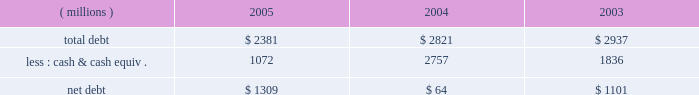Additional information regarding these and other accounting pronouncements is included in note 1 to the consolidated financial statements .
Financial condition and liquidity the company generates significant ongoing cash flow .
Net debt decreased significantly in 2004 , but increased in 2005 , primarily related to the $ 1.36 billion cuno acquisition .
At december 31 .
3m believes its ongoing cash flows provide ample cash to fund expected investments and capital expenditures .
The company has an aa credit rating from standard & poor 2019s and an aa1 credit rating from moody 2019s investors service .
The company has sufficient access to capital markets to meet currently anticipated growth and acquisition investment funding needs .
The company does not utilize derivative instruments linked to the company 2019s stock .
However , the company does have contingently convertible debt that , if conditions for conversion are met , is convertible into shares of 3m common stock ( refer to note 8 in this document ) .
The company 2019s financial condition and liquidity at december 31 , 2005 , remained strong .
Various assets and liabilities , including cash and short-term debt , can fluctuate significantly from month-to-month depending on short-term liquidity needs .
Working capital ( defined as current assets minus current liabilities ) totaled $ 1.877 billion at december 31 , 2005 , compared with $ 2.649 billion at december 31 , 2004 .
This decrease was primarily related to a decrease in cash and cash equivalents ( $ 1.685 billion ) partially offset by a decrease in debt classified as short-term borrowings and current portion of long-term debt ( $ 1.022 billion ) .
The cash and cash equivalents balance was impacted by the acquisition of cuno and repayment of debt .
The company uses various working capital measures that place emphasis and focus on certain working capital assets and liabilities .
These measures are not defined under u.s .
Generally accepted accounting principles and may not be computed the same as similarly titled measures used by other companies .
One of the primary working capital measures 3m uses is a combined index , which includes accounts receivables , inventory and accounts payable .
This combined index ( defined as quarterly net sales 2013 fourth quarter at year-end 2013 multiplied by four , divided by ending net accounts receivable plus inventory less accounts payable ) was 5.7 at december 31 , 2005 , down from 5.8 at december 31 , 2004 .
Excluding cuno , net working capital turns at december 31 , 2005 , were 5.8 , the same as at december 31 , 2004 .
Receivables increased $ 46 million , or 1.6% ( 1.6 % ) , compared with december 31 , 2004 .
At december 31 , 2005 , the cuno acquisition increased accounts receivable by $ 88 million .
Currency translation ( due to the stronger u.s dollar ) reduced accounts receivable by $ 231 million year-on-year .
Inventories increased $ 265 million , or 14.0% ( 14.0 % ) , compared with december 31 , 2004 .
At december 31 , 2005 , the cuno acquisition increased inventories by $ 56 million .
Currency translation reduced inventories by $ 89 million year-on-year .
Accounts payable increased $ 88 million compared with december 31 , 2004 , with cuno accounting for $ 18 million of this increase .
Cash flows from operating , investing and financing activities are provided in the tables that follow .
Individual amounts in the consolidated statement of cash flows exclude the effects of acquisitions , divestitures and exchange rate impacts , which are presented separately in the cash flows .
Thus , the amounts presented in the following operating , investing and financing activities tables reflect changes in balances from period to period adjusted for these effects. .
In 2005 what was the ratio of the debt to the cash? 
Rationale: in 2005 the ratio of the total debt to the cash was 2.2 to 1
Computations: (2381 / 1072)
Answer: 2.22108. 